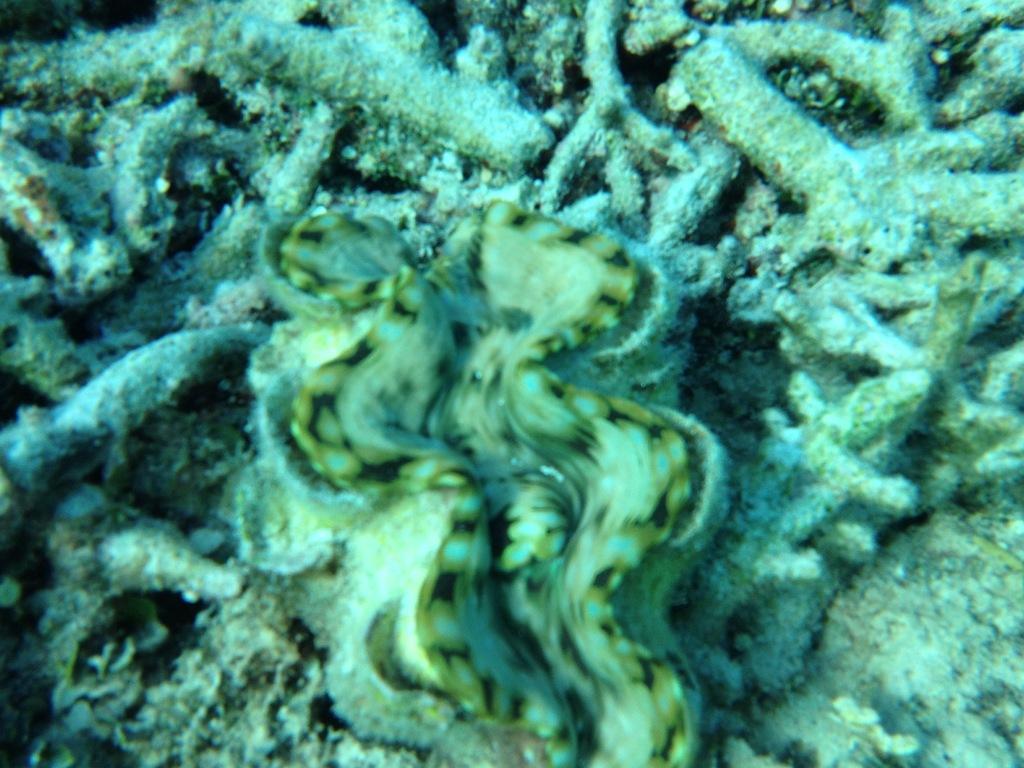Can you describe this image briefly? In this picture, we see the Tridacna clam and some aquatic animals. 